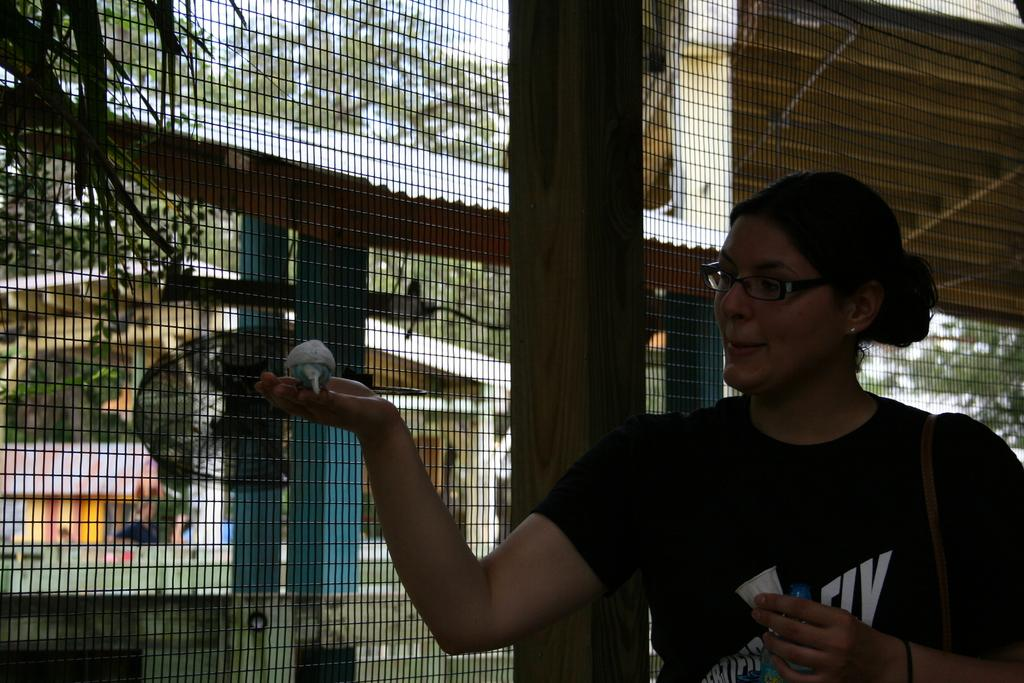Who is present in the image? There is a woman in the image. Where is the woman located in the image? The woman is standing at the right side. What is the woman wearing? The woman is wearing a black t-shirt. What is the woman holding in the image? There is a bird on the woman's palm. What can be seen in the background of the image? There is a fence, buildings, and trees in the background. What type of ink can be seen on the woman's t-shirt in the image? There is no ink visible on the woman's t-shirt in the image. 